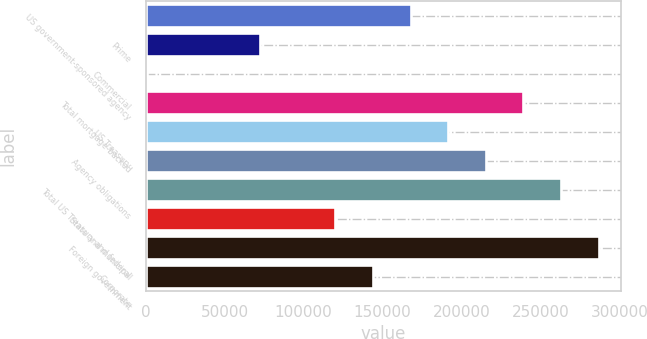Convert chart to OTSL. <chart><loc_0><loc_0><loc_500><loc_500><bar_chart><fcel>US government-sponsored agency<fcel>Prime<fcel>Commercial<fcel>Total mortgage-backed<fcel>US Treasury<fcel>Agency obligations<fcel>Total US Treasury and federal<fcel>State and municipal<fcel>Foreign government<fcel>Corporate<nl><fcel>167713<fcel>72381.7<fcel>883<fcel>239212<fcel>191546<fcel>215379<fcel>263045<fcel>120048<fcel>286878<fcel>143880<nl></chart> 